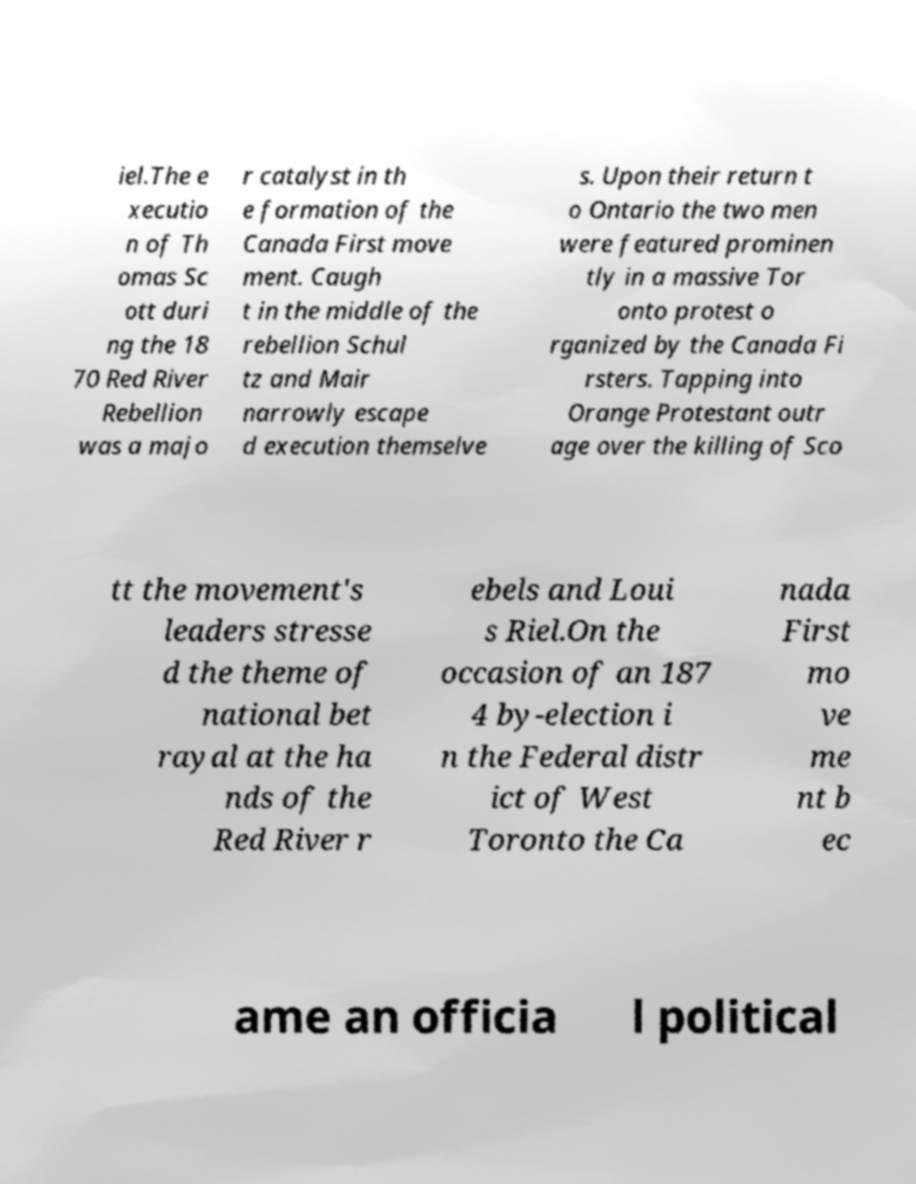Could you assist in decoding the text presented in this image and type it out clearly? iel.The e xecutio n of Th omas Sc ott duri ng the 18 70 Red River Rebellion was a majo r catalyst in th e formation of the Canada First move ment. Caugh t in the middle of the rebellion Schul tz and Mair narrowly escape d execution themselve s. Upon their return t o Ontario the two men were featured prominen tly in a massive Tor onto protest o rganized by the Canada Fi rsters. Tapping into Orange Protestant outr age over the killing of Sco tt the movement's leaders stresse d the theme of national bet rayal at the ha nds of the Red River r ebels and Loui s Riel.On the occasion of an 187 4 by-election i n the Federal distr ict of West Toronto the Ca nada First mo ve me nt b ec ame an officia l political 